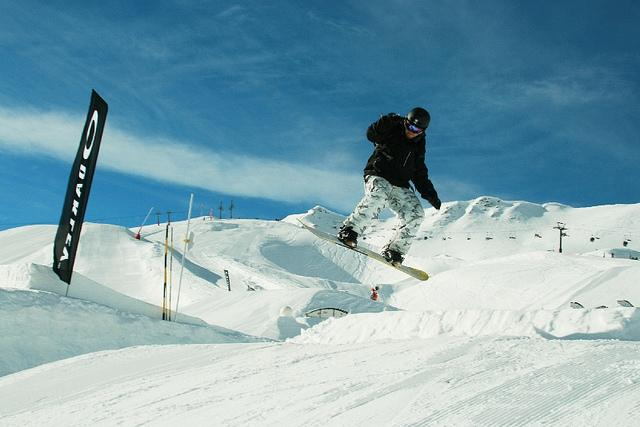Why is the black banner most likely flying in the snowboarder's location? Please explain your reasoning. advertisement. Normally at sporting events, sponsors pay money to have their logos displayed to attract publicity to their brand. 